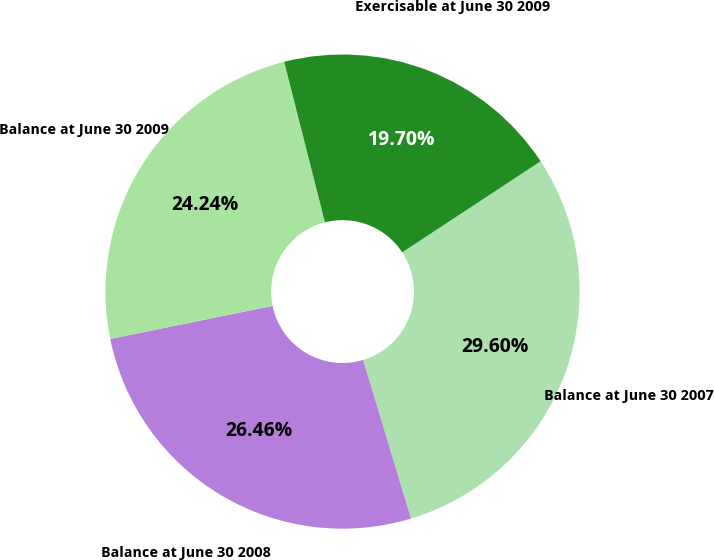Convert chart. <chart><loc_0><loc_0><loc_500><loc_500><pie_chart><fcel>Balance at June 30 2007<fcel>Balance at June 30 2008<fcel>Balance at June 30 2009<fcel>Exercisable at June 30 2009<nl><fcel>29.6%<fcel>26.46%<fcel>24.24%<fcel>19.7%<nl></chart> 